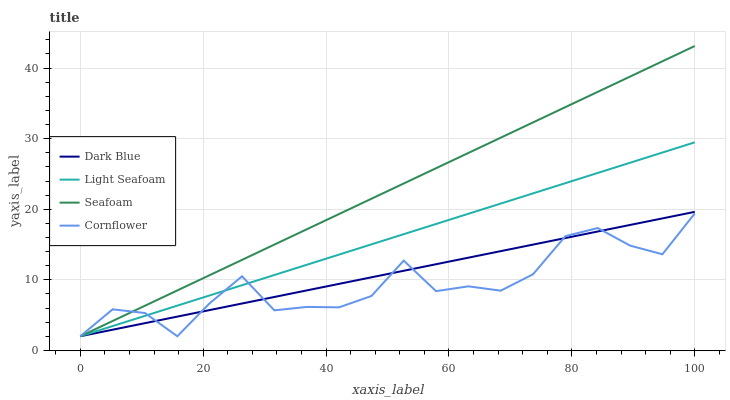Does Cornflower have the minimum area under the curve?
Answer yes or no. Yes. Does Seafoam have the maximum area under the curve?
Answer yes or no. Yes. Does Light Seafoam have the minimum area under the curve?
Answer yes or no. No. Does Light Seafoam have the maximum area under the curve?
Answer yes or no. No. Is Seafoam the smoothest?
Answer yes or no. Yes. Is Cornflower the roughest?
Answer yes or no. Yes. Is Light Seafoam the smoothest?
Answer yes or no. No. Is Light Seafoam the roughest?
Answer yes or no. No. Does Dark Blue have the lowest value?
Answer yes or no. Yes. Does Seafoam have the highest value?
Answer yes or no. Yes. Does Light Seafoam have the highest value?
Answer yes or no. No. Does Light Seafoam intersect Seafoam?
Answer yes or no. Yes. Is Light Seafoam less than Seafoam?
Answer yes or no. No. Is Light Seafoam greater than Seafoam?
Answer yes or no. No. 